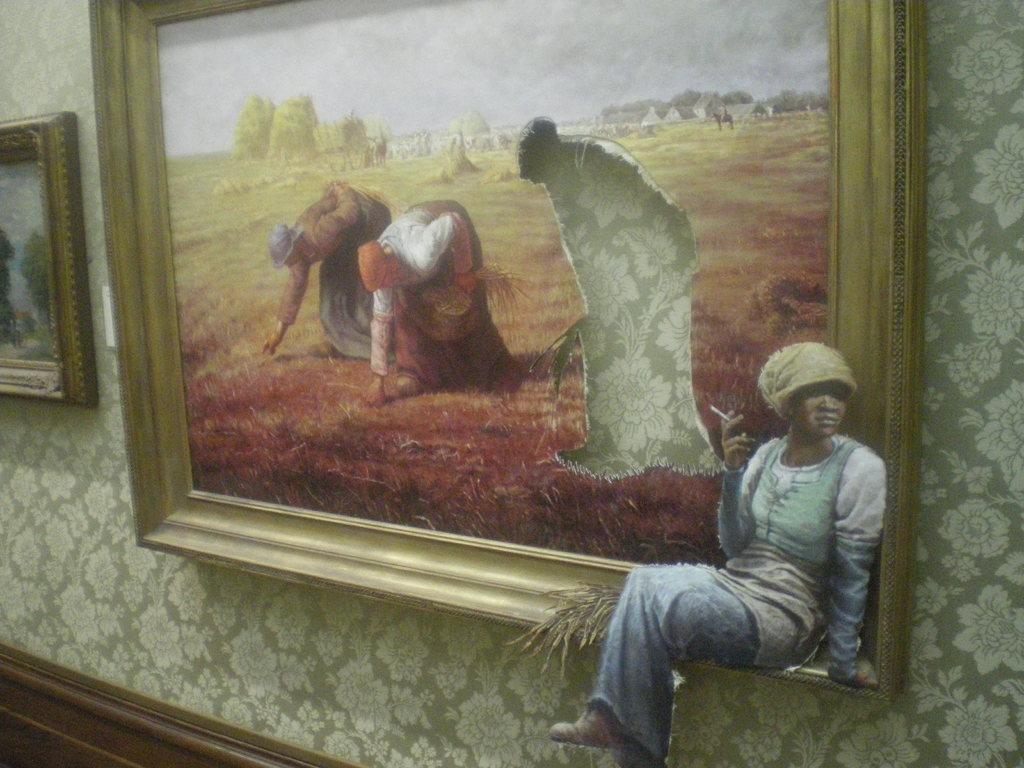Describe this image in one or two sentences. In this image, we can see a photo frame on the wall contains depiction of persons. There is an another photo frame on the left side of the image. 